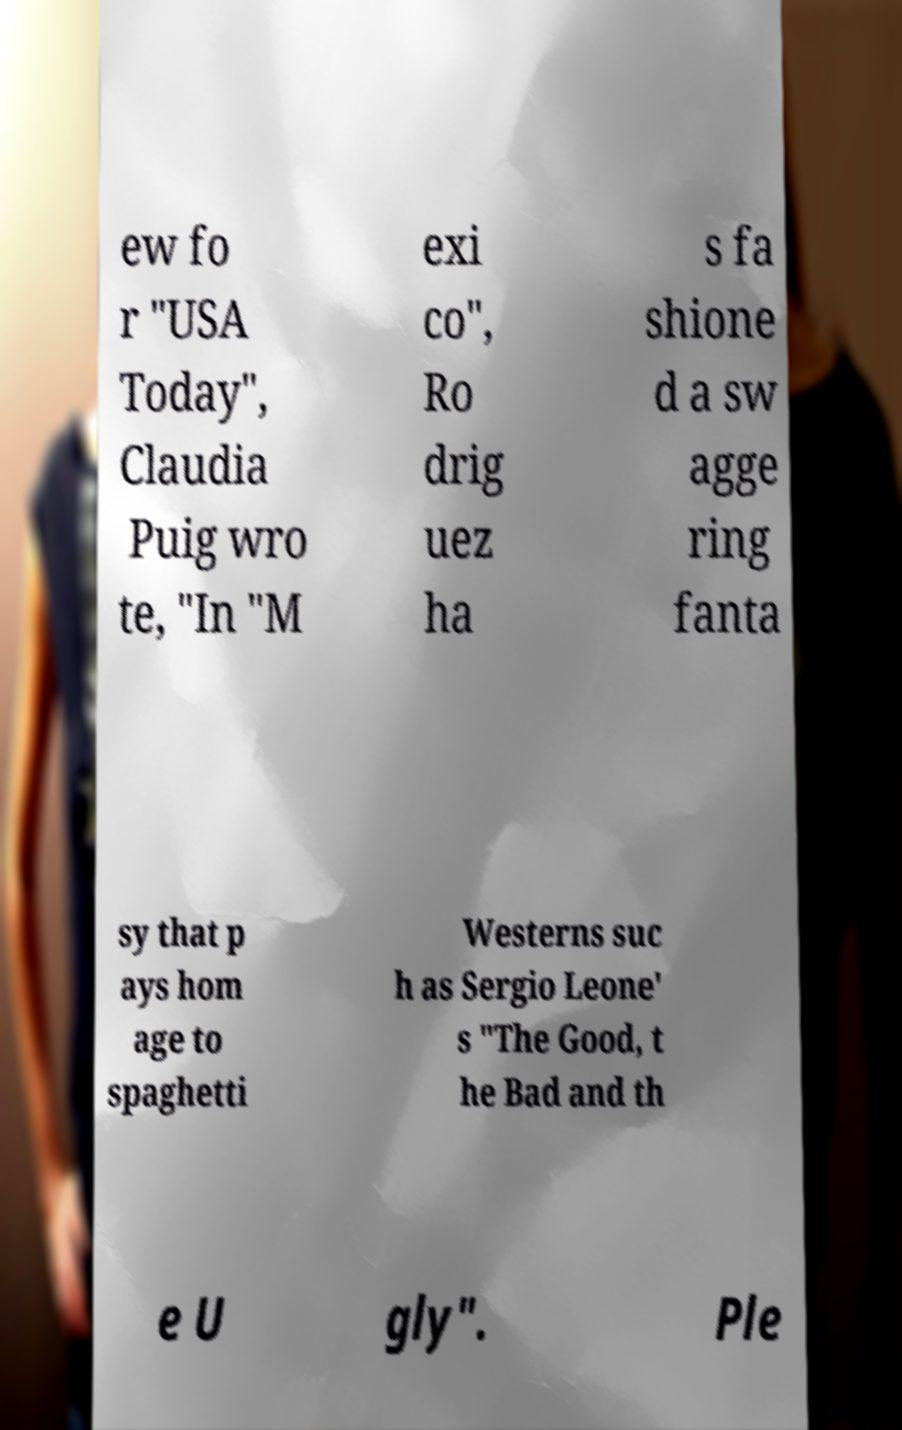Could you assist in decoding the text presented in this image and type it out clearly? ew fo r "USA Today", Claudia Puig wro te, "In "M exi co", Ro drig uez ha s fa shione d a sw agge ring fanta sy that p ays hom age to spaghetti Westerns suc h as Sergio Leone' s "The Good, t he Bad and th e U gly". Ple 